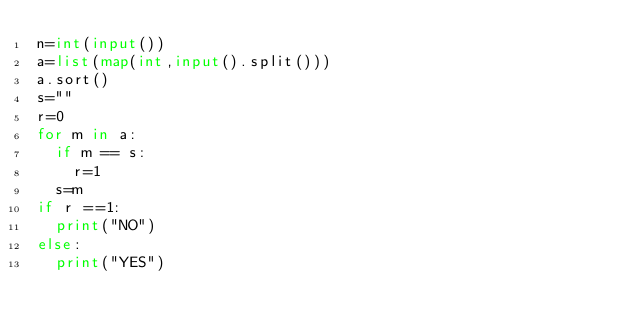Convert code to text. <code><loc_0><loc_0><loc_500><loc_500><_Python_>n=int(input())
a=list(map(int,input().split()))
a.sort()
s=""
r=0
for m in a:
  if m == s:
    r=1
  s=m
if r ==1:
  print("NO")
else:
  print("YES")
</code> 